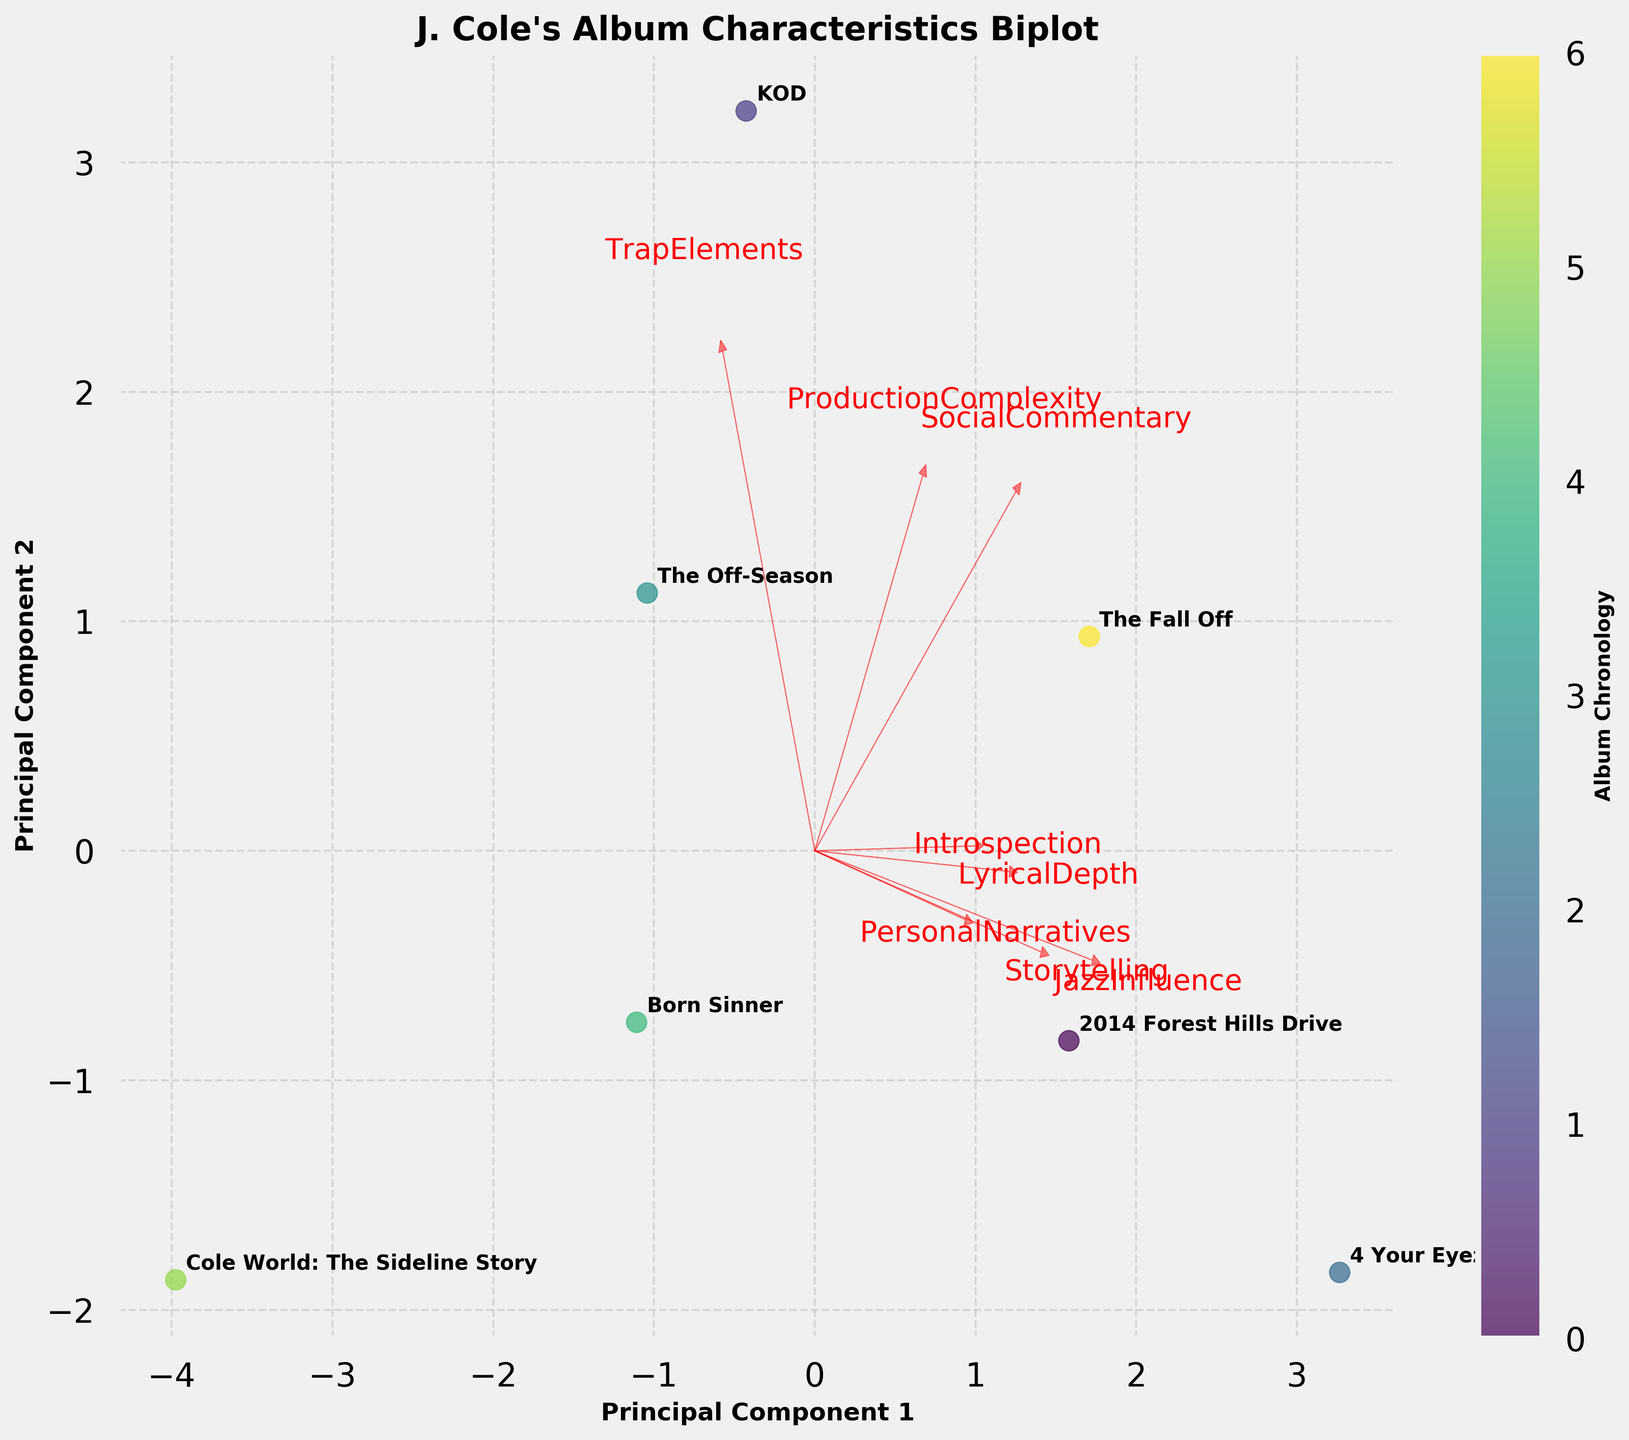what is the title of the biplot? The title is usually displayed prominently at the top of the figure. In this case, it would be stated in bold and larger font size compared to other text elements.
Answer: J. Cole's Album Characteristics Biplot Which two albums have the highest loading in Principal Component 1 (PC1)? To find this, look at the scatter plot points and locate the two with the highest (rightmost) values along the x-axis.
Answer: 4 Your Eyez Only and 2014 Forest Hills Drive Which album features the most complex production? Production complexity is represented by one of the feature vectors. Locate the arrow labeled "ProductionComplexity" and find the data point closest to its tip.
Answer: KOD How are "Social Commentary" and "Trap Elements" visually related in the biplot? Identify the vectors labeled "SocialCommentary" and "TrapElements" and observe their direction and length. If they point in similar directions, they are positively correlated; if opposite, negatively correlated.
Answer: Negatively correlated Which album has the lowest jazz influence? Locate the vector labeled "JazzInfluence" and determine which data point is farthest from the tip of this arrow, in the opposite direction when projections are considered.
Answer: Cole World: The Sideline Story Which two variables show the most similar directional vectors? Find the vectors that have the closest angles between them indicating a high positive correlation.
Answer: Personal Narratives and Storytelling Is there any album that balances between "Introspection" and "Trap Elements"? Look at the location of the data points relative to the vectors labeled "Introspection" and "TrapElements." A balanced album will be situated roughly midway or equidistant from both vectors.
Answer: The Off-Season By inspecting the scatter plot, can you determine which album is the most recent? The color bar provides information on the chronology of the albums. The data point with the highest color value indicates the most recent album.
Answer: The Off-Season What's the principal component (PC) trend for the album "Born Sinner"? Look for "Born Sinner" in the scatter plot and observe its position along both PC1 and PC2 axes to understand trends indicated by distance from the origin.
Answer: Close to average for both PC1 and PC2 